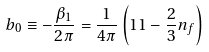<formula> <loc_0><loc_0><loc_500><loc_500>b _ { 0 } \equiv - \frac { \beta _ { 1 } } { 2 \pi } = \frac { 1 } { 4 \pi } \left ( 1 1 - \frac { 2 } { 3 } n _ { f } \right )</formula> 